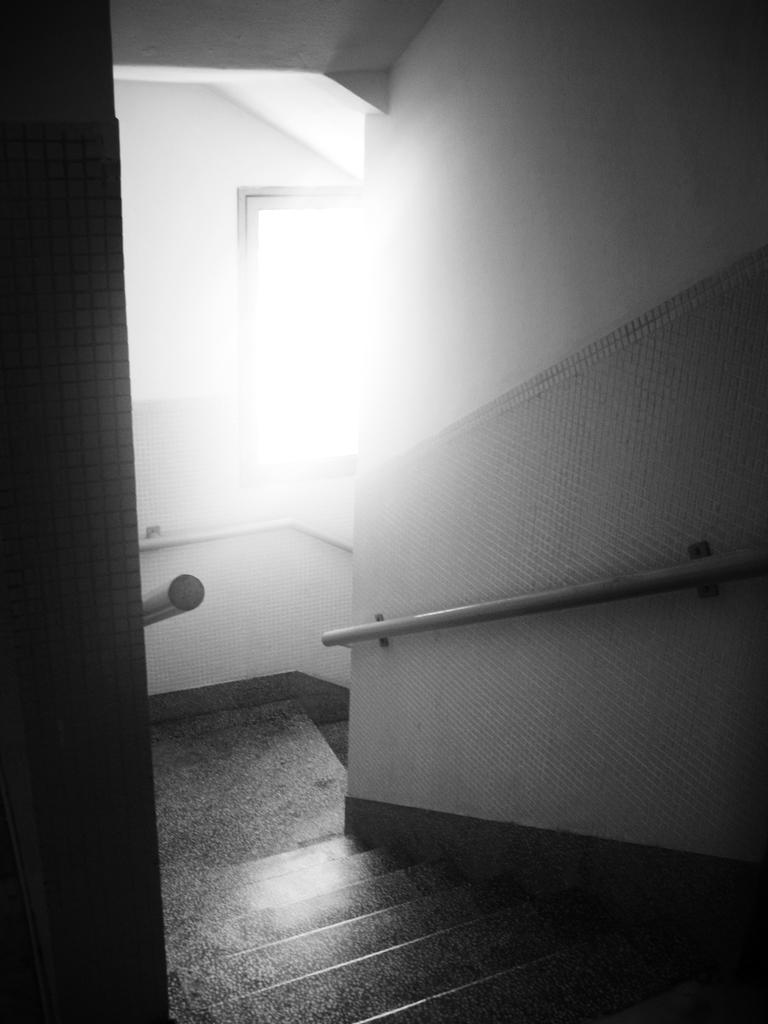What is the color scheme of the image? The image is black and white. What type of architectural feature can be seen in the image? There is a staircase in the image. What is visible in the background of the image? There is a window in the back of the image. What type of van can be seen parked near the staircase in the image? There is no van present in the image; it only features a staircase and a window. What type of soup is being served in the window in the image? There is no soup present in the image; the window is a part of the architectural structure and not a serving area. 